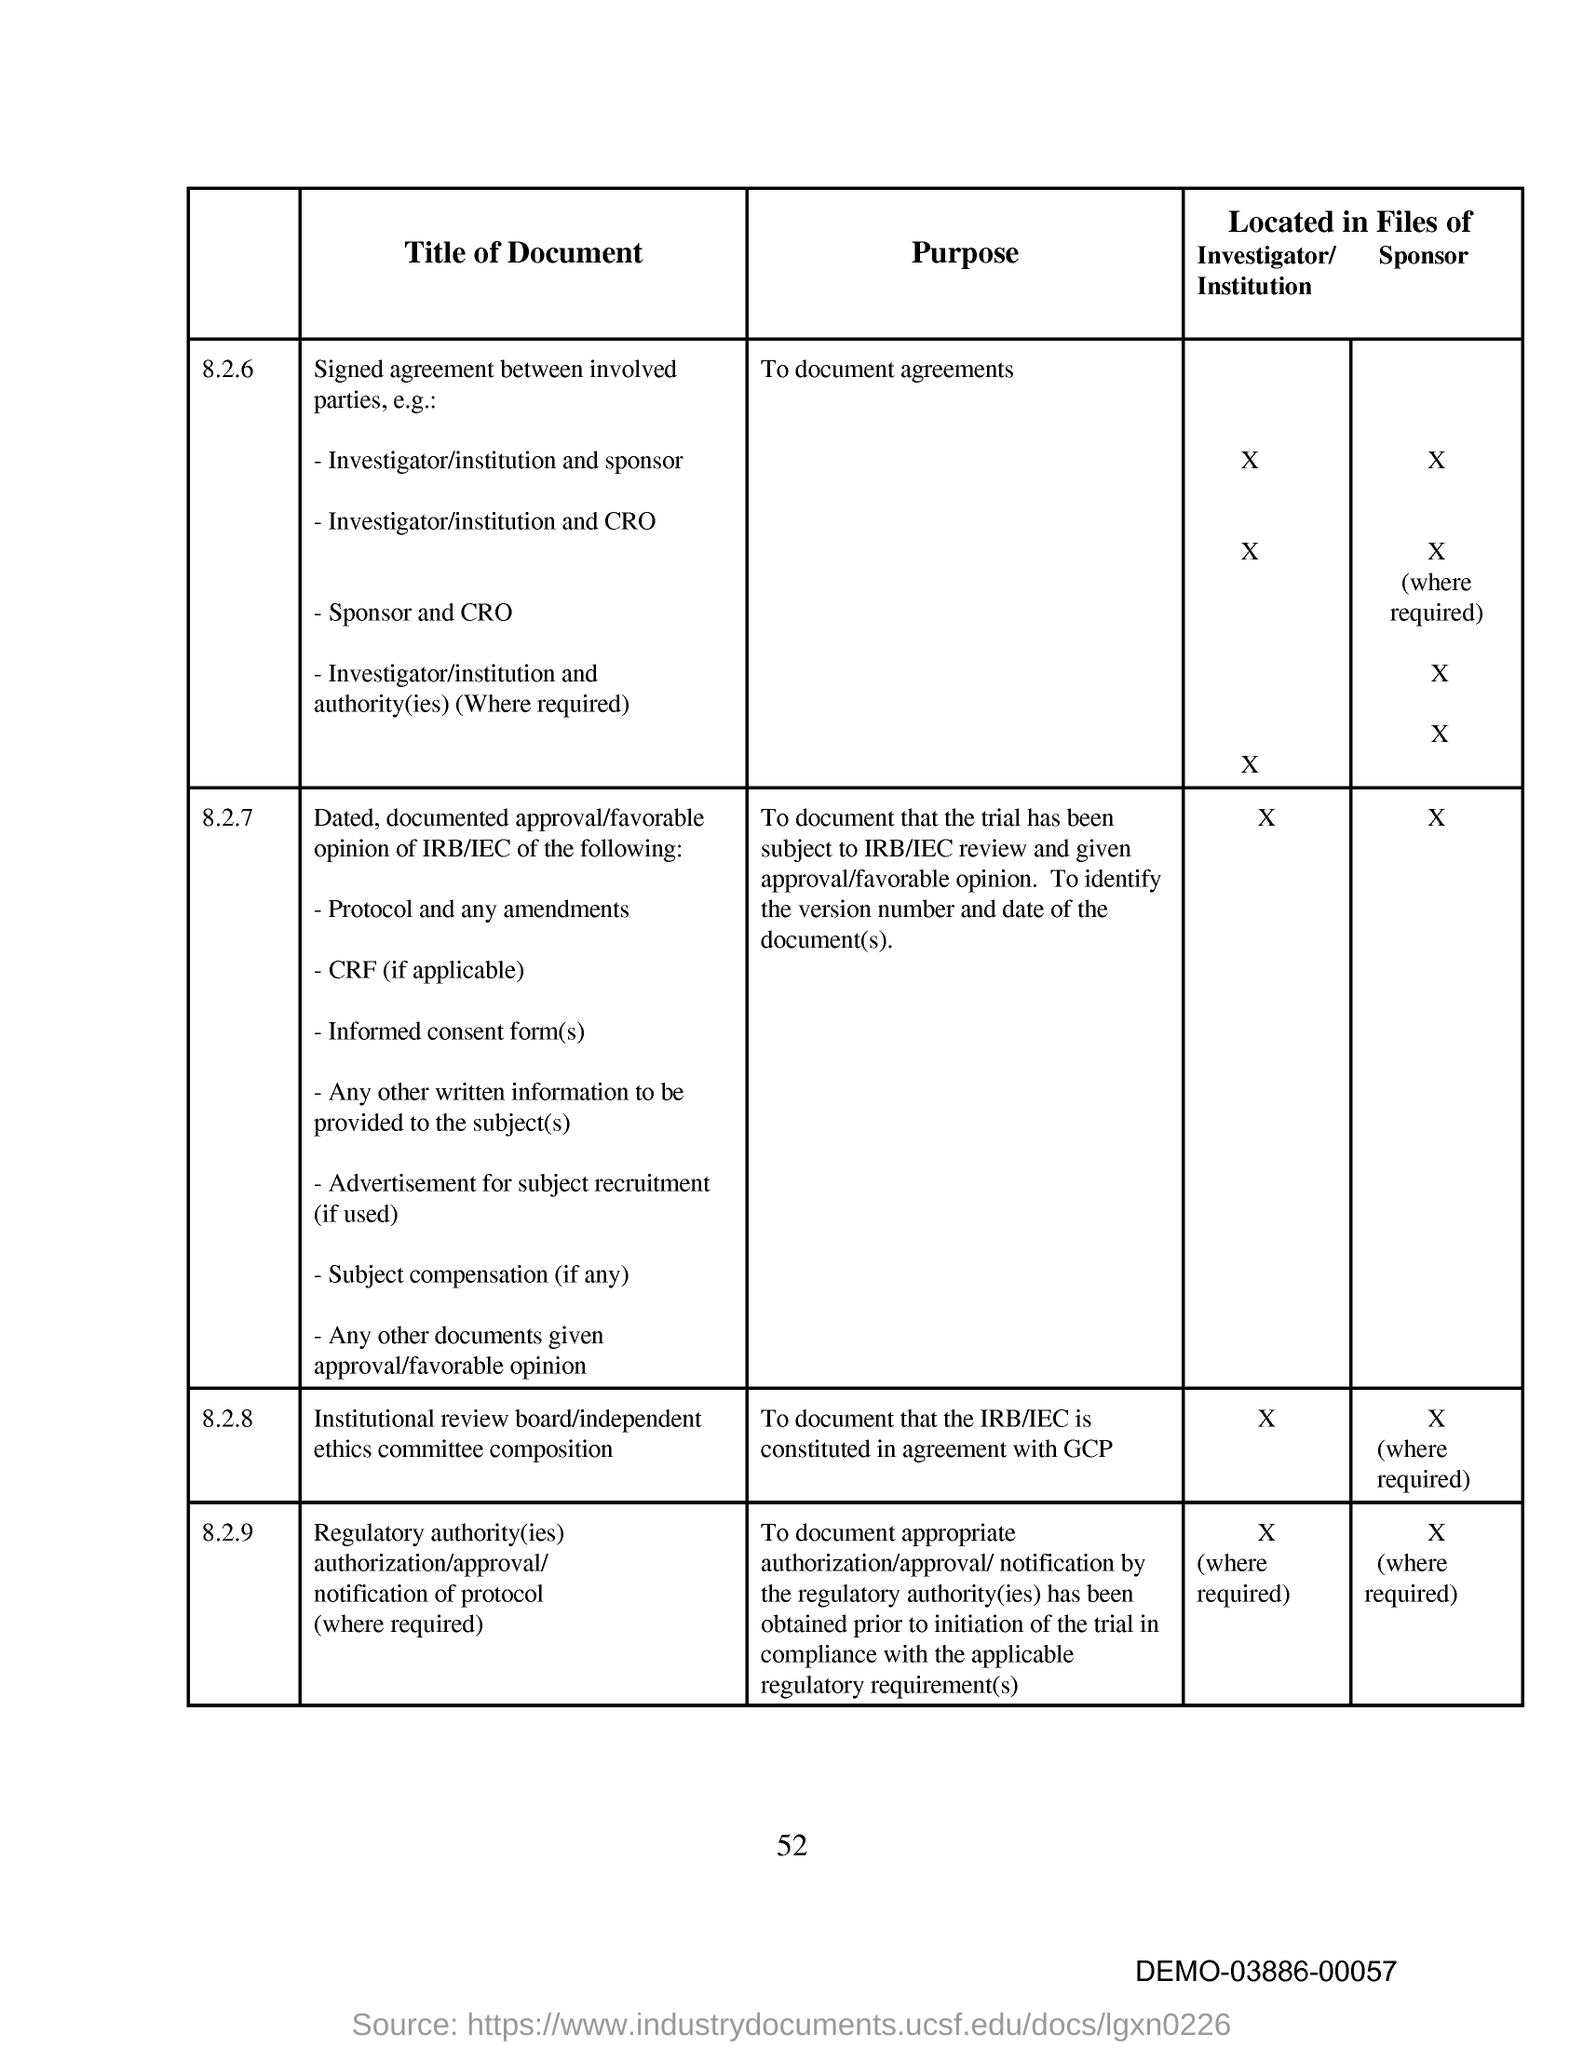Point out several critical features in this image. The page number on this document is 52. The purpose of the document under 8.2.6 is to document agreements. The title of the document under 8.2.8 is 'Institutional Review Board/Independent Ethics Committee Composition.' 